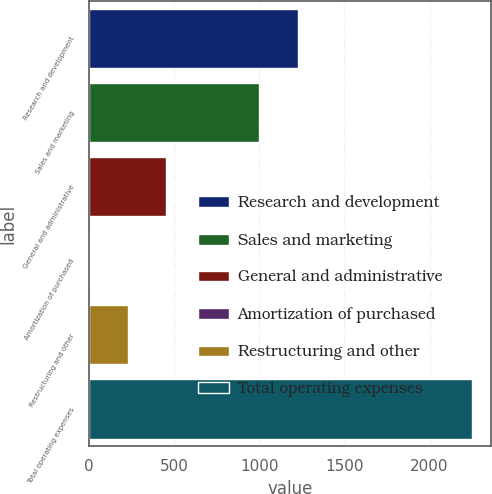Convert chart to OTSL. <chart><loc_0><loc_0><loc_500><loc_500><bar_chart><fcel>Research and development<fcel>Sales and marketing<fcel>General and administrative<fcel>Amortization of purchased<fcel>Restructuring and other<fcel>Total operating expenses<nl><fcel>1225.57<fcel>1001.1<fcel>454.34<fcel>5.4<fcel>229.87<fcel>2250.1<nl></chart> 